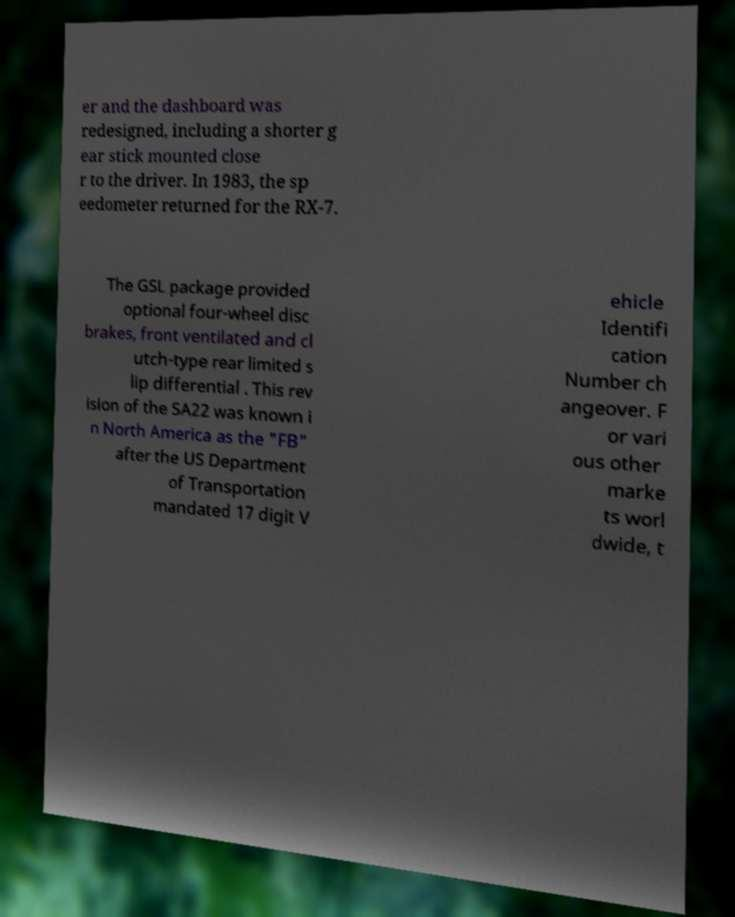I need the written content from this picture converted into text. Can you do that? er and the dashboard was redesigned, including a shorter g ear stick mounted close r to the driver. In 1983, the sp eedometer returned for the RX-7. The GSL package provided optional four-wheel disc brakes, front ventilated and cl utch-type rear limited s lip differential . This rev ision of the SA22 was known i n North America as the "FB" after the US Department of Transportation mandated 17 digit V ehicle Identifi cation Number ch angeover. F or vari ous other marke ts worl dwide, t 